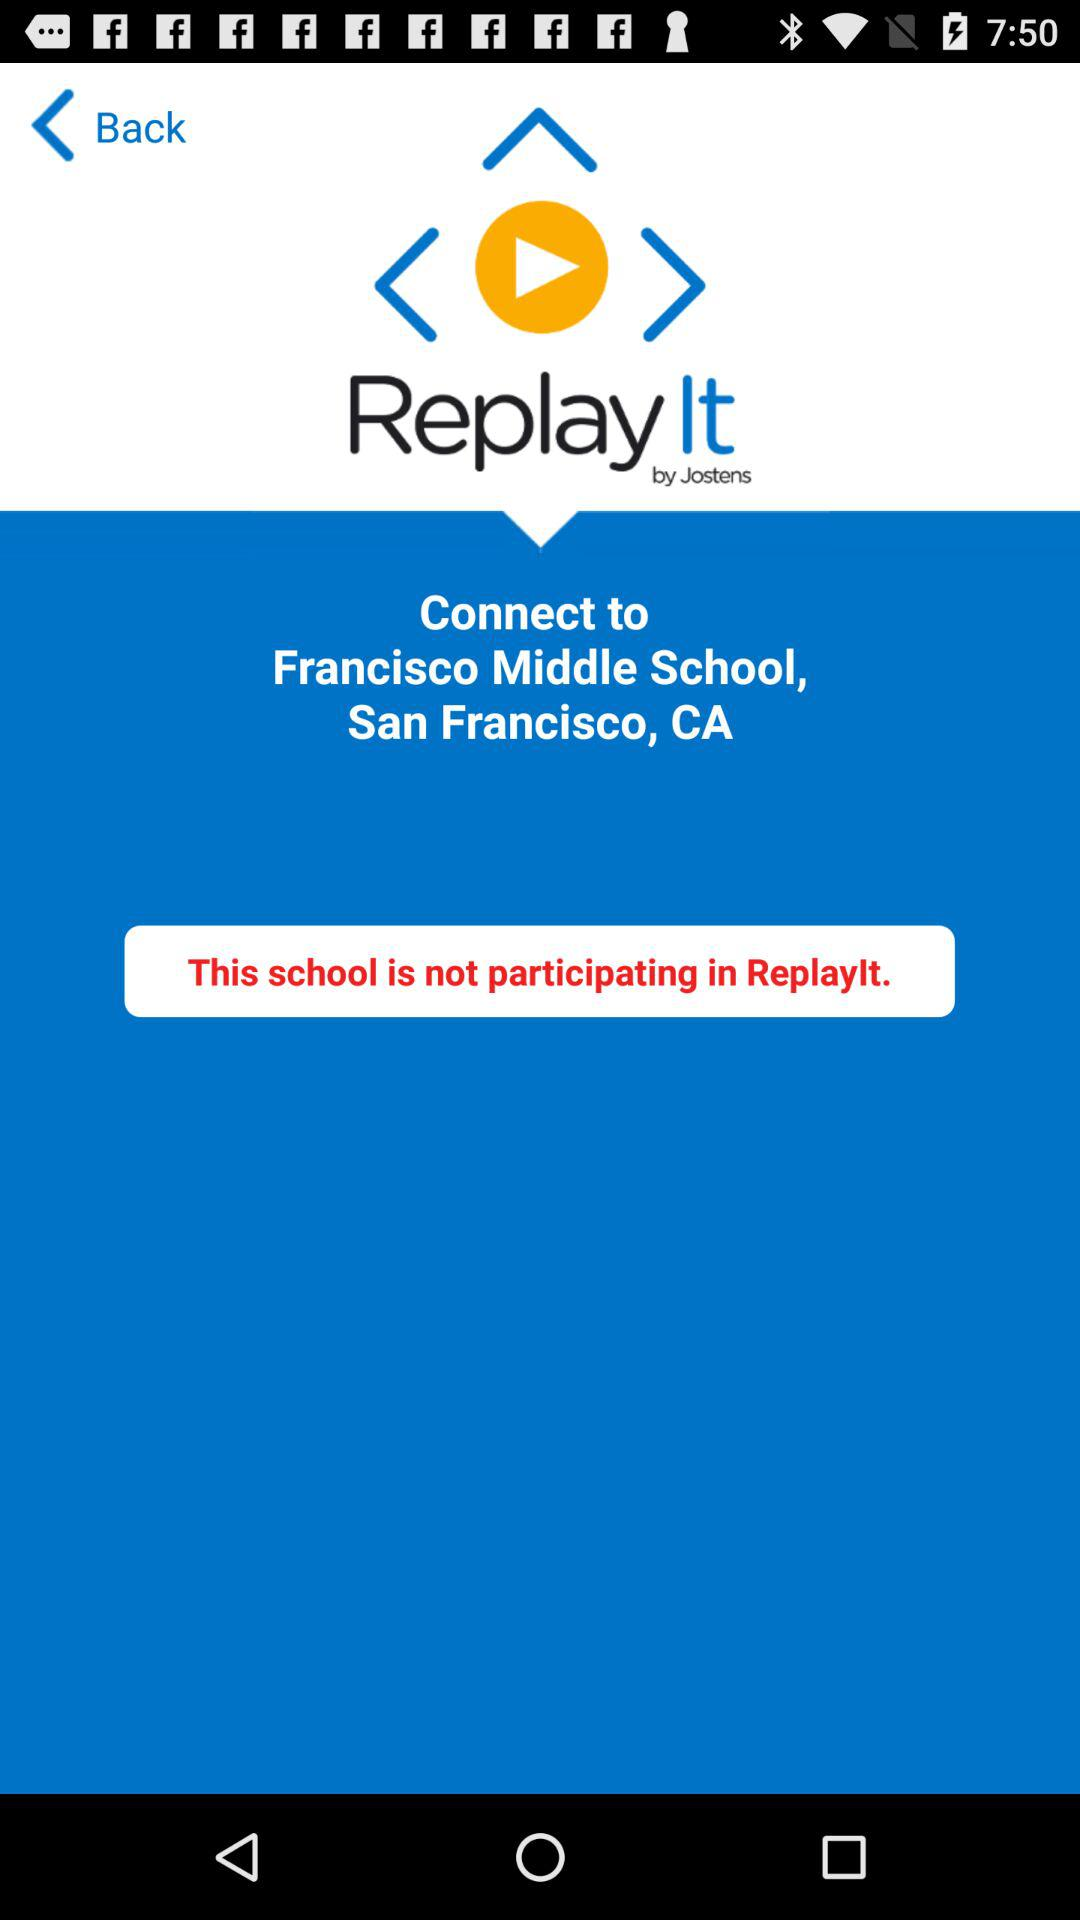What is given location? The given location is Francisco Middle School, San Francisco, CA. 